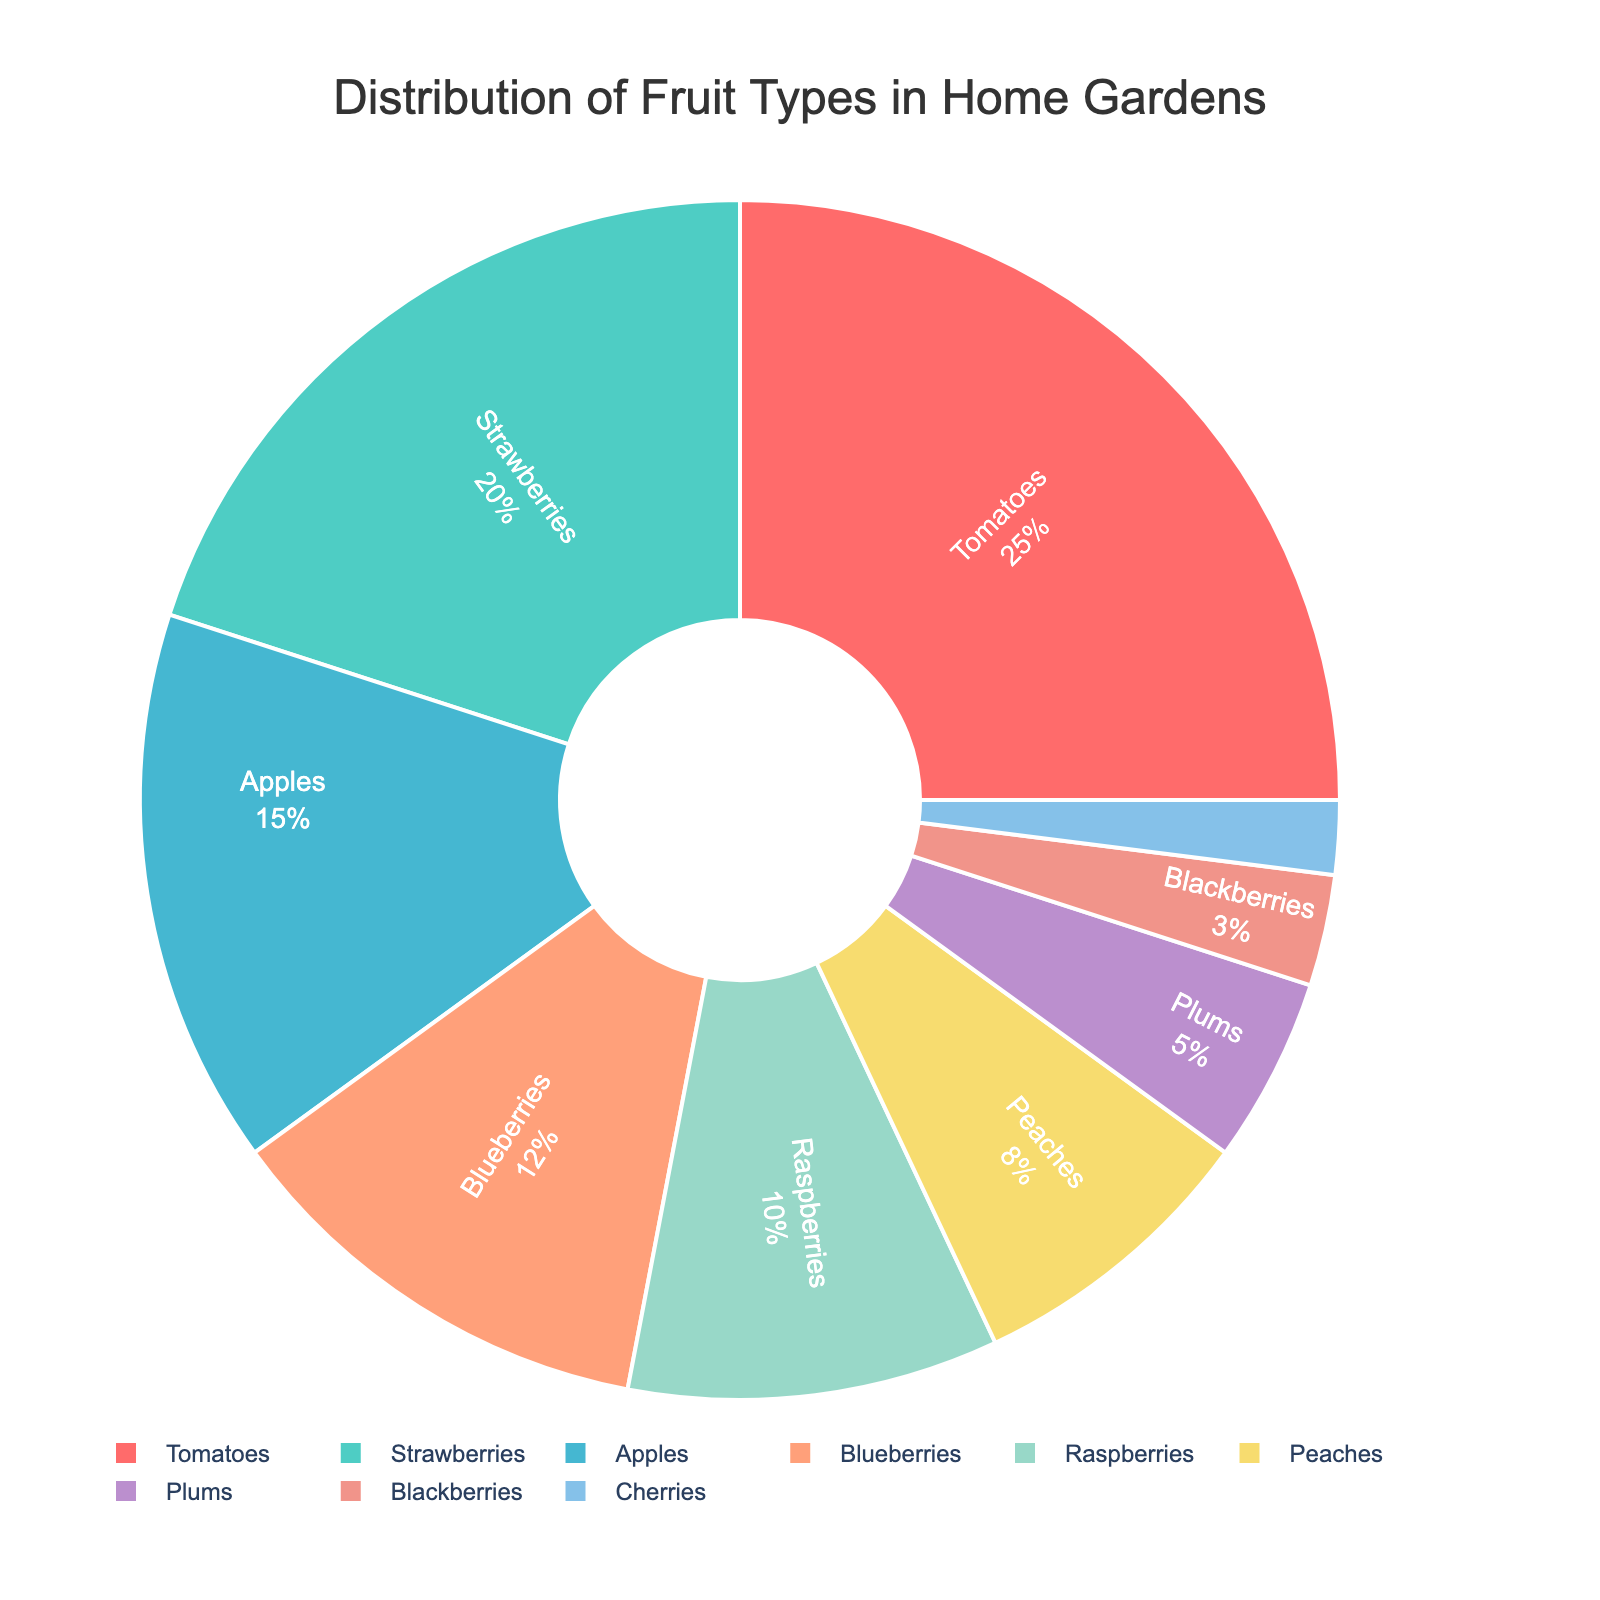Which fruit type is most commonly grown in home gardens? The slice representing Tomatoes is the largest portion of the pie chart.
Answer: Tomatoes Which fruit types make up more than 20% of the distribution? The slices for Tomatoes and Strawberries combined exceed 20%.
Answer: Tomatoes, Strawberries What is the combined percentage of Apples, Blueberries, and Raspberries? Apples are 15%, Blueberries are 12%, and Raspberries are 10%. Summing these gives 15% + 12% + 10% = 37%.
Answer: 37% Which fruit type has the smallest representation in the chart? The smallest slice is the one representing Cherries at 2%.
Answer: Cherries How do Tomatoes compare to Plums in terms of percentage? Tomatoes are 25% whereas Plums are only 5%. Therefore, Tomatoes are greater than Plums.
Answer: Tomatoes are greater than Plums If a neighbor grows an equal amount of Strawberries and Blueberries, what is the total percentage of their garden dedicated to these two fruits? Strawberries make up 20% and Blueberries 12%; together, they make 32%.
Answer: 32% Is the percentage of fruit types that are berries (Strawberries, Blueberries, Raspberries, Blackberries) more or less than half of the distribution? Sum up the percentages of all berries: Strawberries 20% + Blueberries 12% + Raspberries 10% + Blackberries 3% = 45%, which is less than 50%.
Answer: Less than half How much greater is the percentage of Tomatoes compared to Blackberries? Tomatoes are 25% and Blackberries are 3%, so the difference is 25% - 3% = 22%.
Answer: 22% Which color represents the Apples slice? Look for the slice that occupies 15% and it is displayed in blue color.
Answer: Blue What fraction of the garden distribution do Peaches and Plums together constitute? Peaches make up 8% and Plums 5%, summing to 13%. In fractional form, 13% is equivalent to 13/100.
Answer: 13/100 